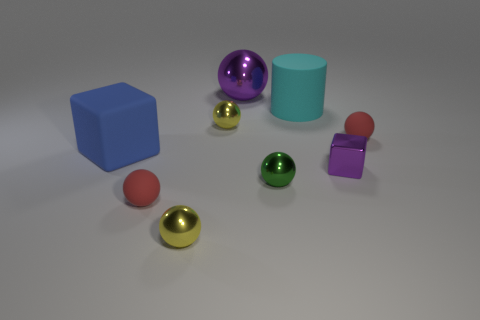What size is the ball that is on the right side of the purple shiny block?
Ensure brevity in your answer.  Small. What is the color of the rubber sphere on the right side of the metal ball that is in front of the red matte thing that is to the left of the large cyan matte object?
Offer a terse response. Red. What color is the sphere behind the large cyan matte thing in front of the big metallic sphere?
Make the answer very short. Purple. Is the number of cyan cylinders that are in front of the small green sphere greater than the number of cyan rubber cylinders behind the big matte cylinder?
Offer a terse response. No. Does the large block in front of the purple shiny sphere have the same material as the small red object that is behind the blue block?
Ensure brevity in your answer.  Yes. There is a big sphere; are there any tiny blocks to the left of it?
Keep it short and to the point. No. What number of green objects are tiny rubber spheres or small cubes?
Provide a short and direct response. 0. Is the large cube made of the same material as the small purple object that is in front of the blue thing?
Provide a short and direct response. No. What size is the purple metallic thing that is the same shape as the large blue object?
Offer a very short reply. Small. What material is the small green ball?
Offer a very short reply. Metal. 